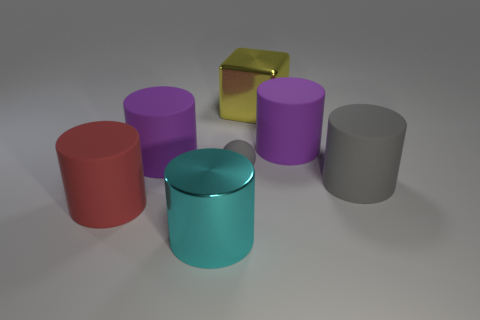How many other things are there of the same material as the big red cylinder?
Offer a terse response. 4. What material is the cyan cylinder that is the same size as the gray cylinder?
Offer a terse response. Metal. Is the shape of the shiny object that is behind the red cylinder the same as the thing that is in front of the red thing?
Provide a short and direct response. No. What shape is the red matte thing that is the same size as the cyan object?
Give a very brief answer. Cylinder. Do the purple thing right of the cyan metal thing and the gray object behind the gray cylinder have the same material?
Give a very brief answer. Yes. Are there any tiny matte objects on the left side of the large purple rubber cylinder left of the yellow shiny block?
Keep it short and to the point. No. What color is the small thing that is the same material as the large gray cylinder?
Make the answer very short. Gray. Is the number of large yellow metallic objects greater than the number of tiny purple shiny things?
Give a very brief answer. Yes. How many objects are big matte things that are behind the tiny gray ball or big yellow blocks?
Give a very brief answer. 3. Is there a gray ball of the same size as the yellow object?
Keep it short and to the point. No. 